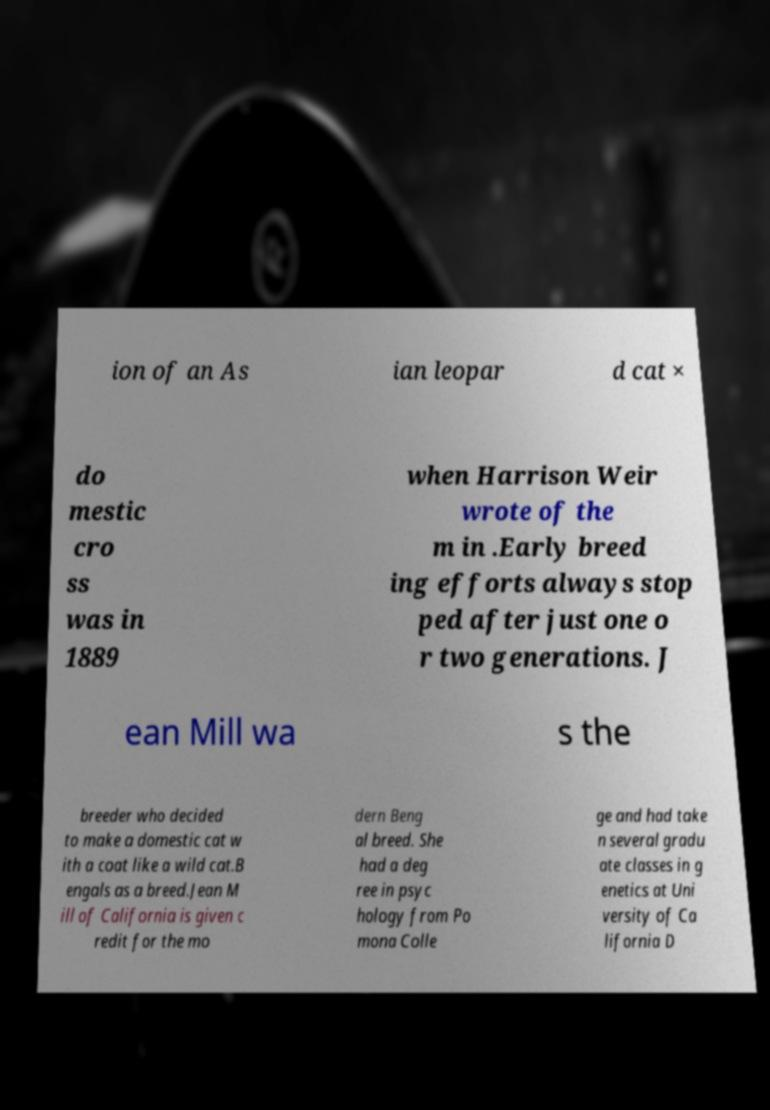Please identify and transcribe the text found in this image. ion of an As ian leopar d cat × do mestic cro ss was in 1889 when Harrison Weir wrote of the m in .Early breed ing efforts always stop ped after just one o r two generations. J ean Mill wa s the breeder who decided to make a domestic cat w ith a coat like a wild cat.B engals as a breed.Jean M ill of California is given c redit for the mo dern Beng al breed. She had a deg ree in psyc hology from Po mona Colle ge and had take n several gradu ate classes in g enetics at Uni versity of Ca lifornia D 